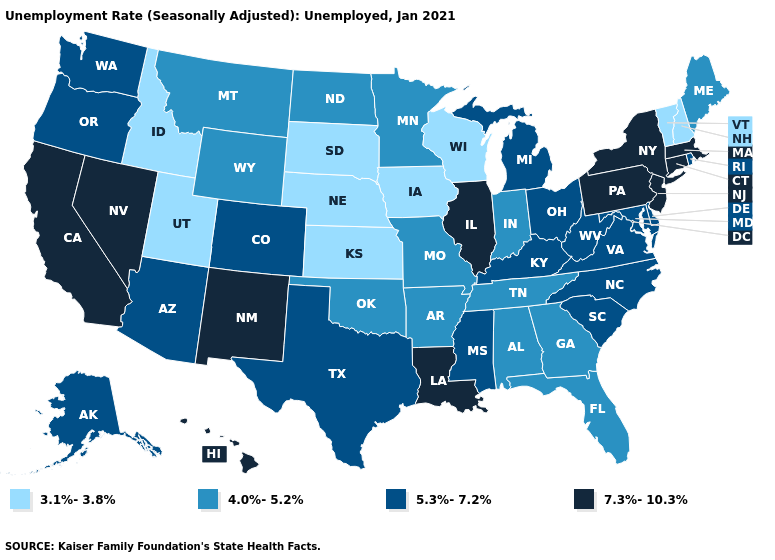What is the value of Georgia?
Give a very brief answer. 4.0%-5.2%. What is the highest value in the South ?
Concise answer only. 7.3%-10.3%. What is the lowest value in states that border South Carolina?
Write a very short answer. 4.0%-5.2%. What is the highest value in the South ?
Write a very short answer. 7.3%-10.3%. Among the states that border Colorado , which have the lowest value?
Quick response, please. Kansas, Nebraska, Utah. What is the value of Massachusetts?
Write a very short answer. 7.3%-10.3%. What is the highest value in the Northeast ?
Be succinct. 7.3%-10.3%. What is the value of Maryland?
Write a very short answer. 5.3%-7.2%. What is the value of Kansas?
Keep it brief. 3.1%-3.8%. Does Nevada have the highest value in the USA?
Answer briefly. Yes. What is the value of California?
Give a very brief answer. 7.3%-10.3%. Among the states that border Tennessee , does Kentucky have the lowest value?
Write a very short answer. No. Name the states that have a value in the range 3.1%-3.8%?
Keep it brief. Idaho, Iowa, Kansas, Nebraska, New Hampshire, South Dakota, Utah, Vermont, Wisconsin. What is the lowest value in the USA?
Write a very short answer. 3.1%-3.8%. 